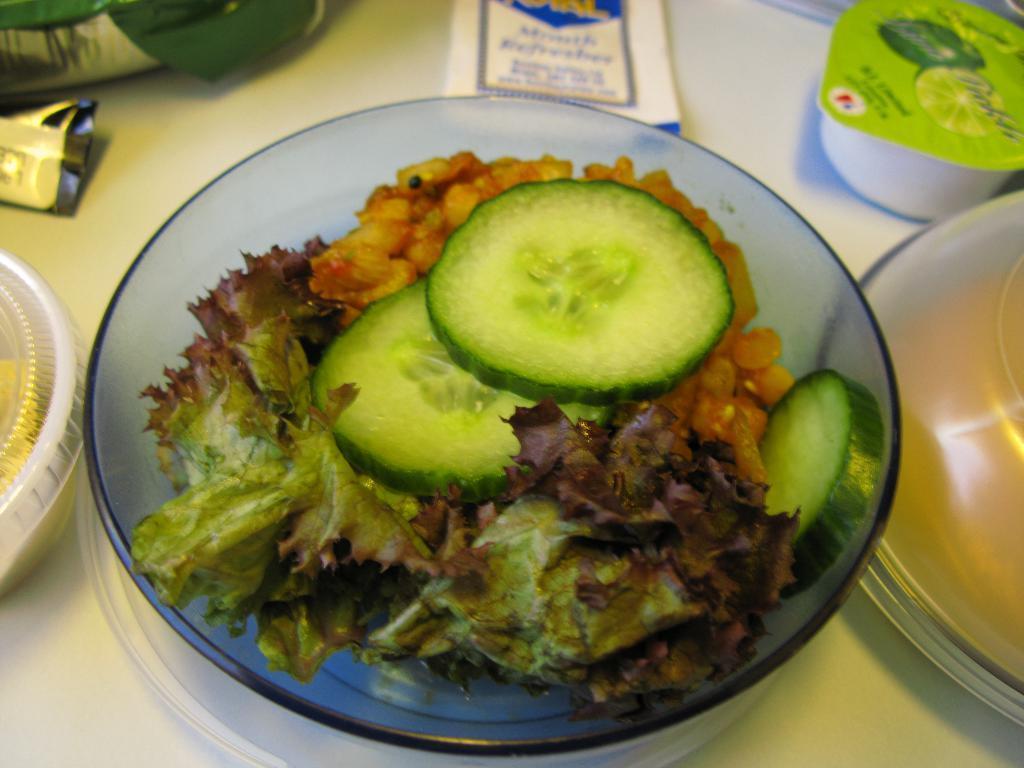How would you summarize this image in a sentence or two? At the bottom of the image there is a table with two packets, two boxes, a vessel, a plate and a bowl with cucumber slices and a salad on it. 